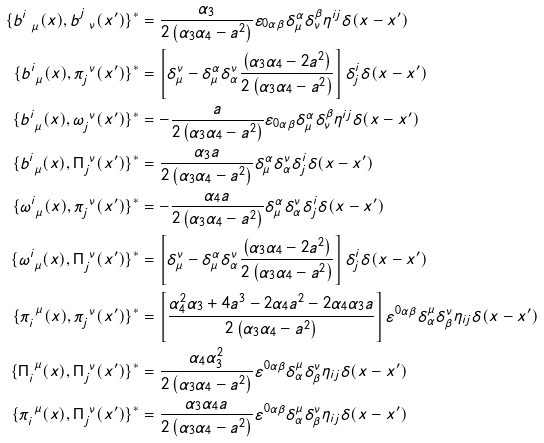<formula> <loc_0><loc_0><loc_500><loc_500>\{ b ^ { i } _ { \ \mu } ( x ) , b ^ { j } _ { \ \nu } ( x ^ { \prime } ) \} ^ { * } & = \frac { \alpha _ { 3 } } { 2 \left ( \alpha _ { 3 } \alpha _ { 4 } - a ^ { 2 } \right ) } \varepsilon _ { 0 \alpha \beta } \delta ^ { \alpha } _ { \mu } \delta ^ { \beta } _ { \nu } \eta ^ { i j } \delta ( x - x ^ { \prime } ) \\ \{ b ^ { i } _ { \ \mu } ( x ) , \pi _ { j } ^ { \ \nu } ( x ^ { \prime } ) \} ^ { * } & = \left [ \delta ^ { \nu } _ { \mu } - \delta ^ { \alpha } _ { \mu } \delta ^ { \nu } _ { \alpha } \frac { \left ( \alpha _ { 3 } \alpha _ { 4 } - 2 a ^ { 2 } \right ) } { 2 \left ( \alpha _ { 3 } \alpha _ { 4 } - a ^ { 2 } \right ) } \right ] \delta ^ { i } _ { j } \delta ( x - x ^ { \prime } ) \\ \{ b ^ { i } _ { \ \mu } ( x ) , \omega _ { j } ^ { \ \nu } ( x ^ { \prime } ) \} ^ { * } & = - \frac { a } { 2 \left ( \alpha _ { 3 } \alpha _ { 4 } - a ^ { 2 } \right ) } \varepsilon _ { 0 \alpha \beta } \delta ^ { \alpha } _ { \mu } \delta ^ { \beta } _ { \nu } \eta ^ { i j } \delta ( x - x ^ { \prime } ) \\ \{ b ^ { i } _ { \ \mu } ( x ) , \Pi ^ { \ \nu } _ { j } ( x ^ { \prime } ) \} ^ { * } & = \frac { \alpha _ { 3 } a } { 2 \left ( \alpha _ { 3 } \alpha _ { 4 } - a ^ { 2 } \right ) } \delta ^ { \alpha } _ { \mu } \delta ^ { \nu } _ { \alpha } \delta ^ { i } _ { j } \delta ( x - x ^ { \prime } ) \\ \{ \omega ^ { i } _ { \ \mu } ( x ) , \pi ^ { \ \nu } _ { j } ( x ^ { \prime } ) \} ^ { * } & = - \frac { \alpha _ { 4 } a } { 2 \left ( \alpha _ { 3 } \alpha _ { 4 } - a ^ { 2 } \right ) } \delta ^ { \alpha } _ { \mu } \delta ^ { \nu } _ { \alpha } \delta ^ { i } _ { j } \delta ( x - x ^ { \prime } ) \\ \{ \omega ^ { i } _ { \ \mu } ( x ) , \Pi ^ { \ \nu } _ { j } ( x ^ { \prime } ) \} ^ { * } & = \left [ \delta ^ { \nu } _ { \mu } - \delta ^ { \alpha } _ { \mu } \delta ^ { \nu } _ { \alpha } \frac { \left ( \alpha _ { 3 } \alpha _ { 4 } - 2 a ^ { 2 } \right ) } { 2 \left ( \alpha _ { 3 } \alpha _ { 4 } - a ^ { 2 } \right ) } \right ] \delta ^ { i } _ { j } \delta ( x - x ^ { \prime } ) \\ \{ \pi _ { i } ^ { \ \mu } ( x ) , \pi ^ { \ \nu } _ { j } ( x ^ { \prime } ) \} ^ { * } & = \left [ \frac { \alpha _ { 4 } ^ { 2 } \alpha _ { 3 } + 4 a ^ { 3 } - 2 \alpha _ { 4 } a ^ { 2 } - 2 \alpha _ { 4 } \alpha _ { 3 } a } { 2 \left ( \alpha _ { 3 } \alpha _ { 4 } - a ^ { 2 } \right ) } \right ] \varepsilon ^ { 0 \alpha \beta } \delta ^ { \mu } _ { \alpha } \delta ^ { \nu } _ { \beta } \eta _ { i j } \delta ( x - x ^ { \prime } ) \\ \{ \Pi _ { i } ^ { \ \mu } ( x ) , \Pi ^ { \ \nu } _ { j } ( x ^ { \prime } ) \} ^ { * } & = \frac { \alpha _ { 4 } \alpha _ { 3 } ^ { 2 } } { 2 \left ( \alpha _ { 3 } \alpha _ { 4 } - a ^ { 2 } \right ) } \varepsilon ^ { 0 \alpha \beta } \delta ^ { \mu } _ { \alpha } \delta ^ { \nu } _ { \beta } \eta _ { i j } \delta ( x - x ^ { \prime } ) \\ \{ \pi _ { i } ^ { \ \mu } ( x ) , \Pi ^ { \ \nu } _ { j } ( x ^ { \prime } ) \} ^ { * } & = \frac { \alpha _ { 3 } \alpha _ { 4 } a } { 2 \left ( \alpha _ { 3 } \alpha _ { 4 } - a ^ { 2 } \right ) } \varepsilon ^ { 0 \alpha \beta } \delta ^ { \mu } _ { \alpha } \delta ^ { \nu } _ { \beta } \eta _ { i j } \delta ( x - x ^ { \prime } ) \\</formula> 